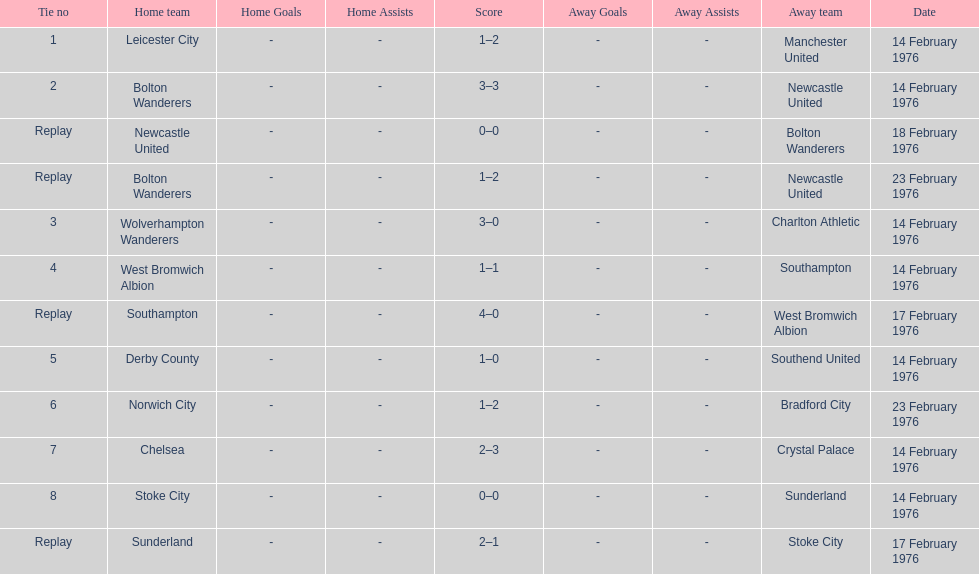How many games were reenactments? 4. Could you help me parse every detail presented in this table? {'header': ['Tie no', 'Home team', 'Home Goals', 'Home Assists', 'Score', 'Away Goals', 'Away Assists', 'Away team', 'Date'], 'rows': [['1', 'Leicester City', '-', '-', '1–2', '-', '-', 'Manchester United', '14 February 1976'], ['2', 'Bolton Wanderers', '-', '-', '3–3', '-', '-', 'Newcastle United', '14 February 1976'], ['Replay', 'Newcastle United', '-', '-', '0–0', '-', '-', 'Bolton Wanderers', '18 February 1976'], ['Replay', 'Bolton Wanderers', '-', '-', '1–2', '-', '-', 'Newcastle United', '23 February 1976'], ['3', 'Wolverhampton Wanderers', '-', '-', '3–0', '-', '-', 'Charlton Athletic', '14 February 1976'], ['4', 'West Bromwich Albion', '-', '-', '1–1', '-', '-', 'Southampton', '14 February 1976'], ['Replay', 'Southampton', '-', '-', '4–0', '-', '-', 'West Bromwich Albion', '17 February 1976'], ['5', 'Derby County', '-', '-', '1–0', '-', '-', 'Southend United', '14 February 1976'], ['6', 'Norwich City', '-', '-', '1–2', '-', '-', 'Bradford City', '23 February 1976'], ['7', 'Chelsea', '-', '-', '2–3', '-', '-', 'Crystal Palace', '14 February 1976'], ['8', 'Stoke City', '-', '-', '0–0', '-', '-', 'Sunderland', '14 February 1976'], ['Replay', 'Sunderland', '-', '-', '2–1', '-', '-', 'Stoke City', '17 February 1976']]} 